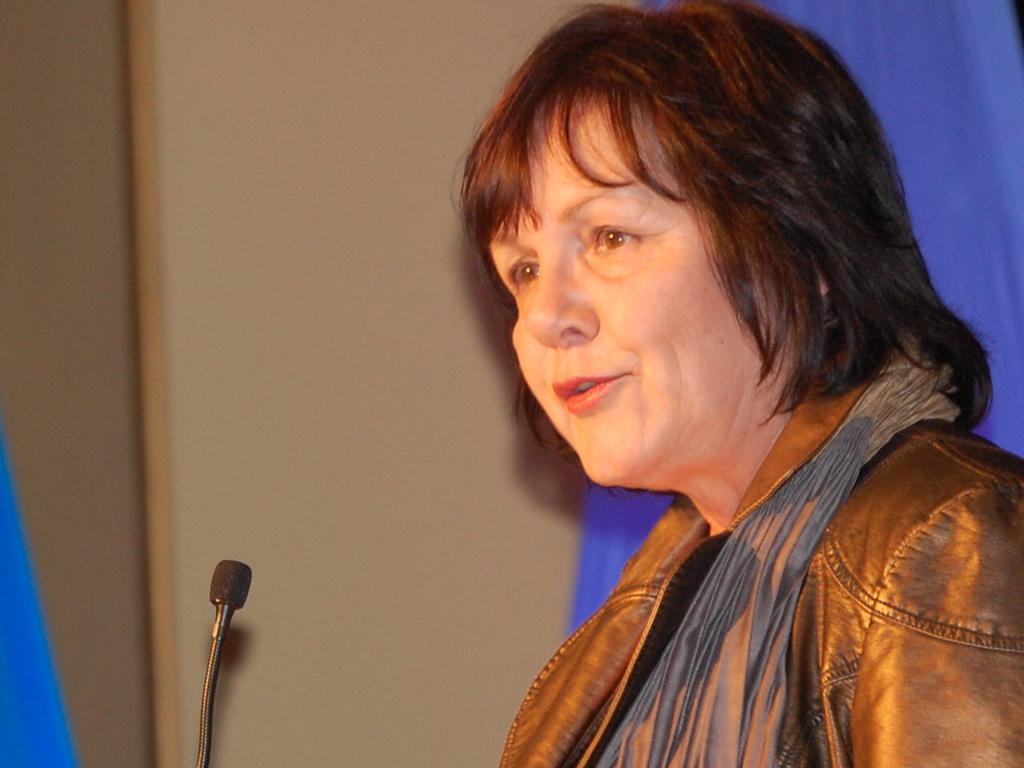Describe this image in one or two sentences. In this picture we can see a woman, a microphone and other objects. 